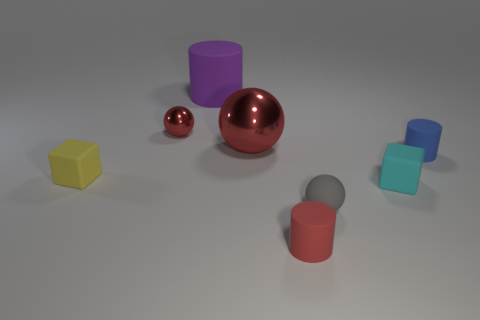Subtract all large cylinders. How many cylinders are left? 2 Add 2 yellow rubber objects. How many objects exist? 10 Subtract all cylinders. How many objects are left? 5 Add 6 yellow objects. How many yellow objects exist? 7 Subtract 0 gray cylinders. How many objects are left? 8 Subtract all big brown rubber spheres. Subtract all tiny matte cubes. How many objects are left? 6 Add 4 rubber things. How many rubber things are left? 10 